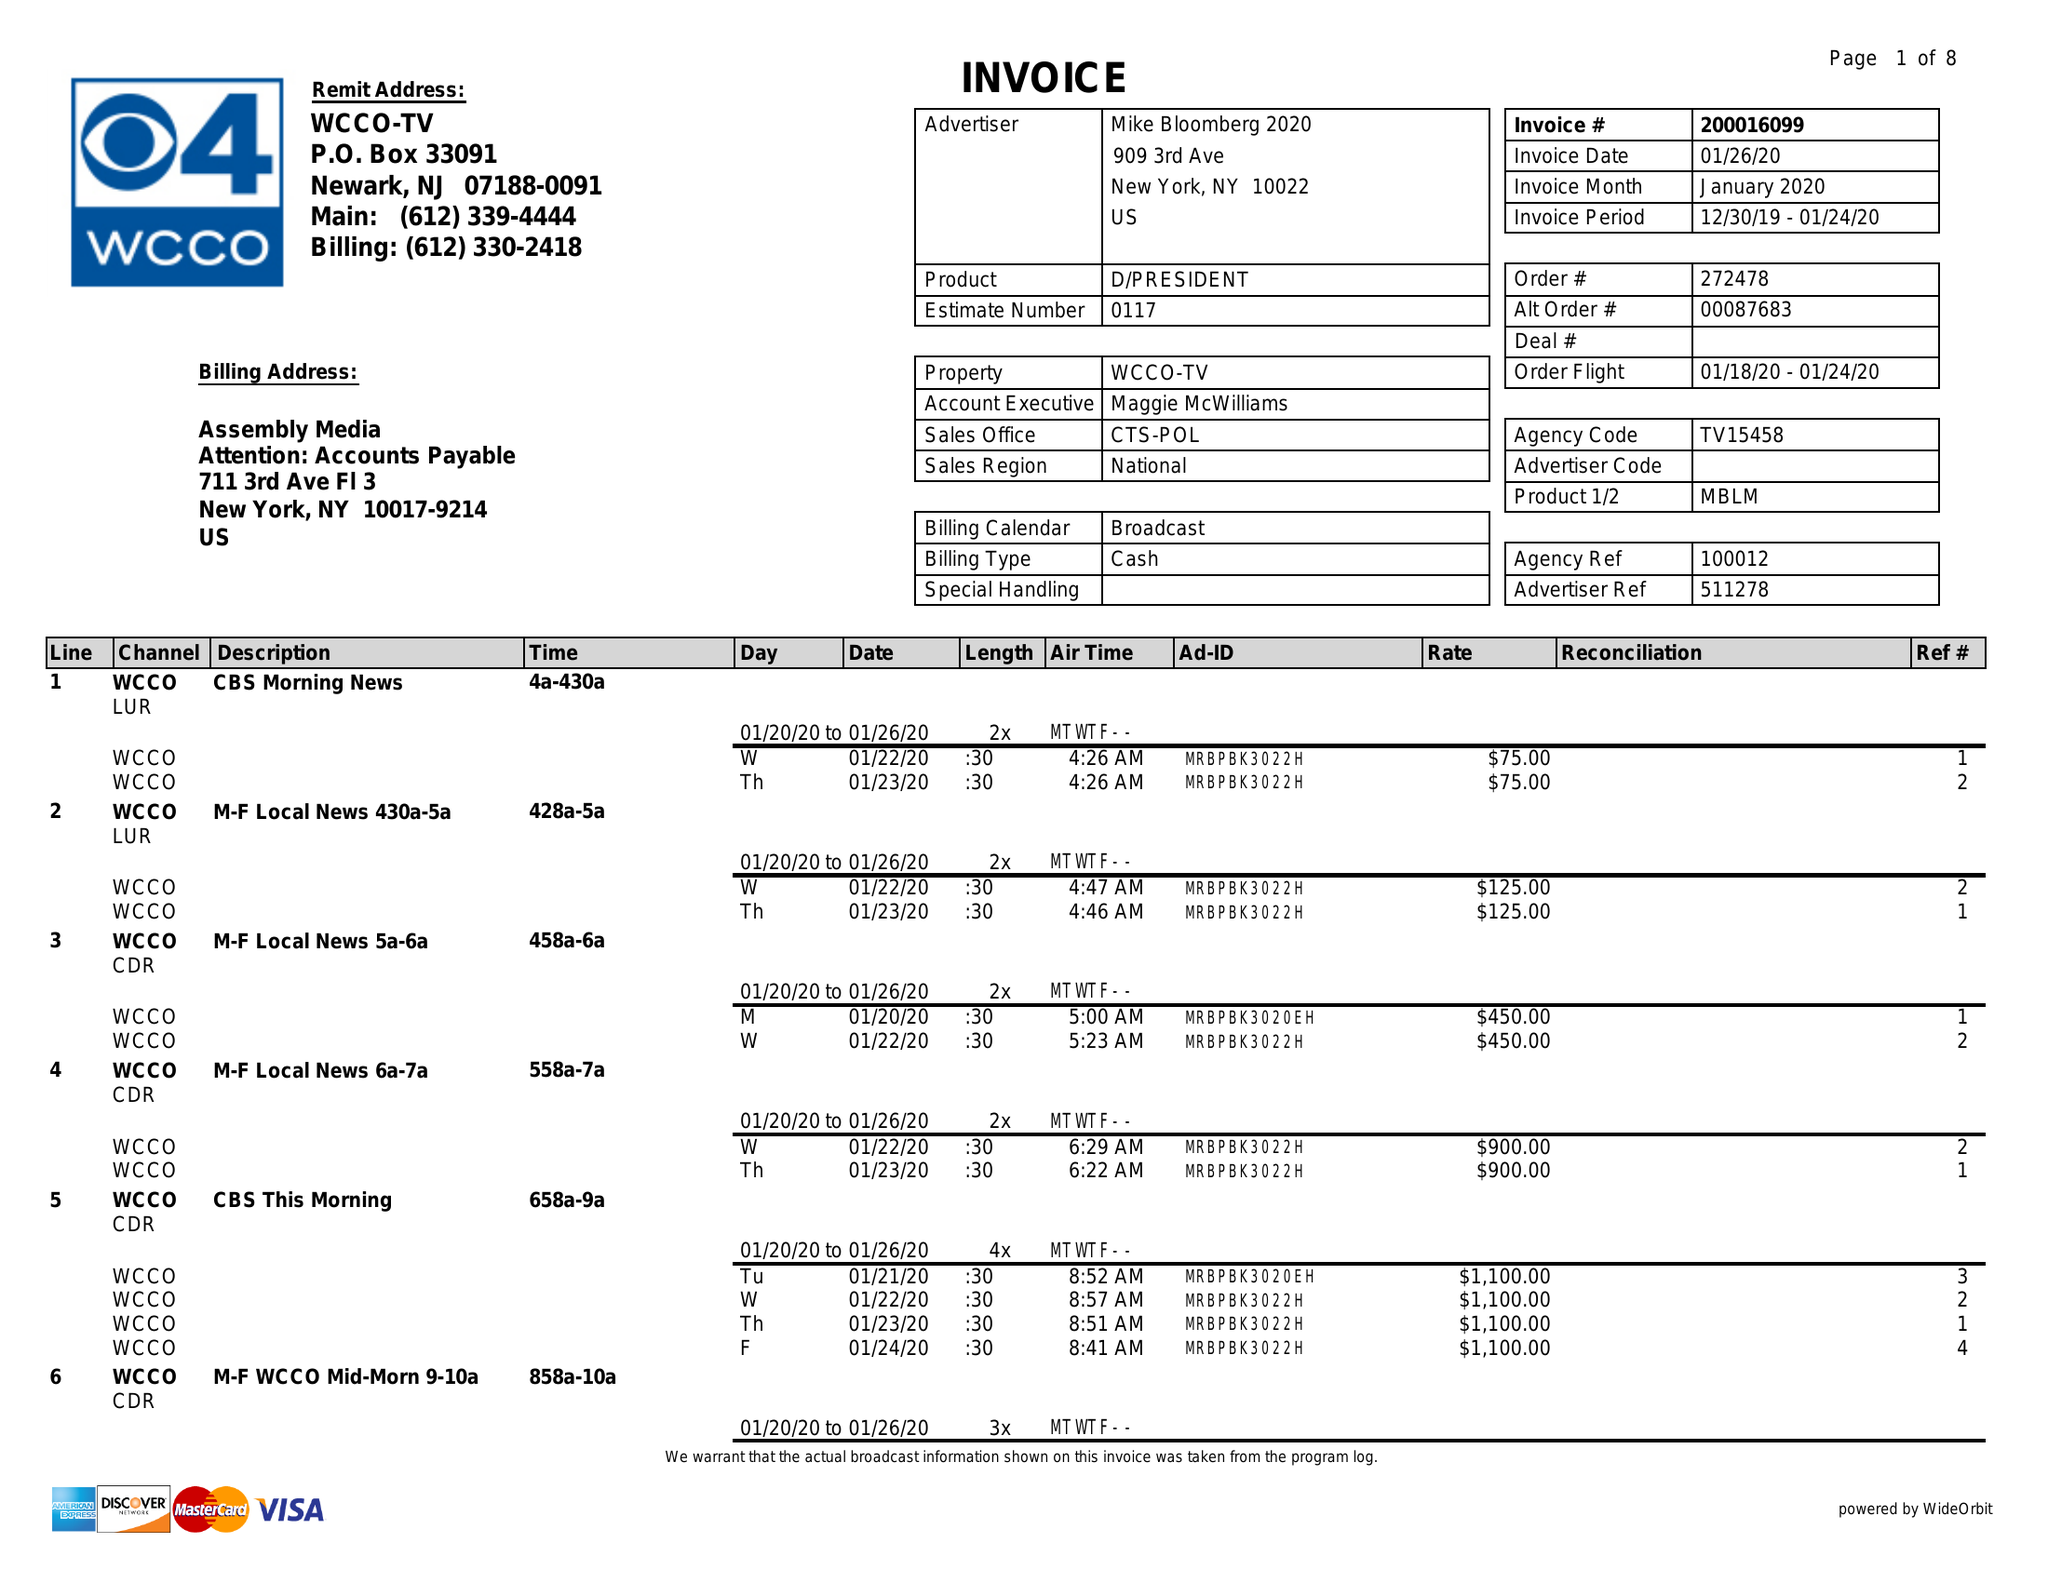What is the value for the flight_from?
Answer the question using a single word or phrase. 01/18/20 